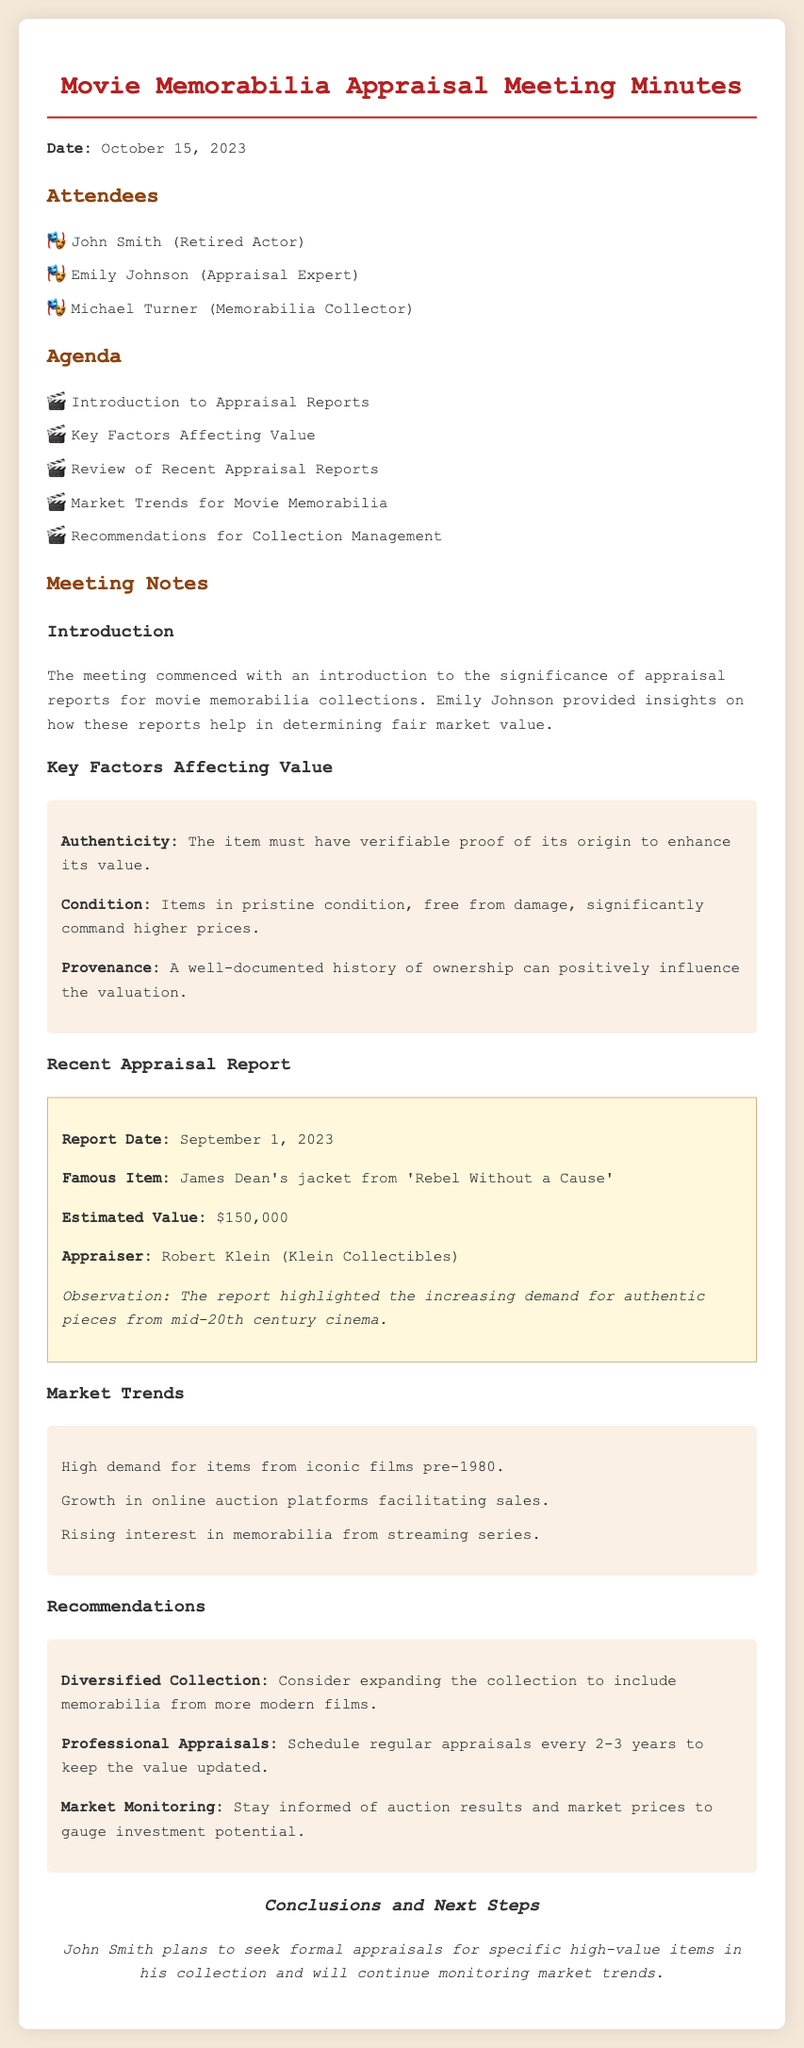What is the date of the meeting? The date of the meeting is mentioned at the top of the document.
Answer: October 15, 2023 Who is the appraisal expert present at the meeting? The appraisal expert is listed in the attendees section of the document.
Answer: Emily Johnson What was the estimated value of James Dean's jacket? This information is provided in the recent appraisal report section of the document.
Answer: $150,000 What is one key factor affecting the value of memorabilia? Key factors are listed under the relevant section in the document.
Answer: Authenticity How often should professional appraisals be scheduled according to recommendations? This can be found in the recommendations section of the document.
Answer: Every 2-3 years What is the famous item reviewed in the recent appraisal report? The notable item is specified in the appraisal report section of the document.
Answer: James Dean's jacket from 'Rebel Without a Cause' What is one market trend for movie memorabilia? Market trends are enumerated in their own section of the document.
Answer: High demand for items from iconic films pre-1980 What conclusion did John Smith reach at the end of the meeting? The conclusion is detailed in the conclusions and next steps section of the document.
Answer: Seek formal appraisals for specific high-value items 